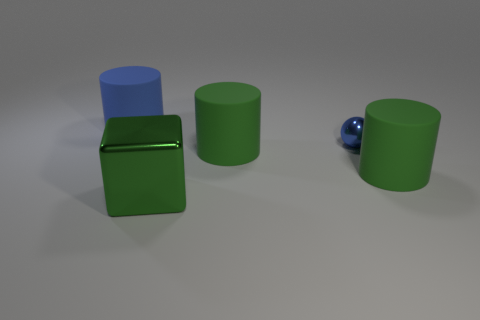Subtract all green rubber cylinders. How many cylinders are left? 1 Subtract 2 cylinders. How many cylinders are left? 1 Subtract all brown cylinders. Subtract all purple balls. How many cylinders are left? 3 Subtract all yellow spheres. How many blue cylinders are left? 1 Subtract all large green cylinders. Subtract all small blue shiny things. How many objects are left? 2 Add 2 green objects. How many green objects are left? 5 Add 5 tiny matte objects. How many tiny matte objects exist? 5 Add 5 blue matte objects. How many objects exist? 10 Subtract all blue cylinders. How many cylinders are left? 2 Subtract 0 brown balls. How many objects are left? 5 